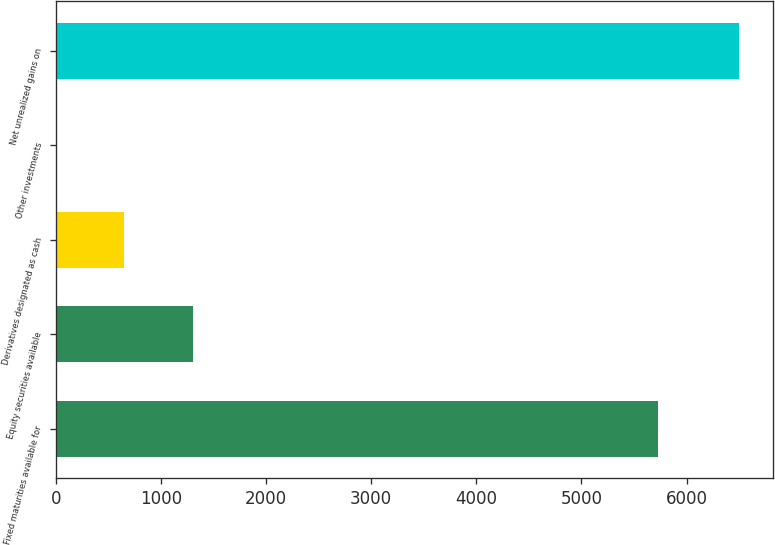Convert chart. <chart><loc_0><loc_0><loc_500><loc_500><bar_chart><fcel>Fixed maturities available for<fcel>Equity securities available<fcel>Derivatives designated as cash<fcel>Other investments<fcel>Net unrealized gains on<nl><fcel>5728<fcel>1302.2<fcel>652.6<fcel>3<fcel>6499<nl></chart> 